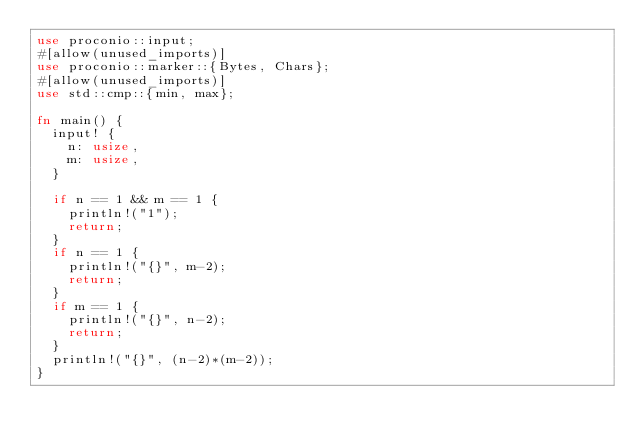<code> <loc_0><loc_0><loc_500><loc_500><_Rust_>use proconio::input;
#[allow(unused_imports)]
use proconio::marker::{Bytes, Chars};
#[allow(unused_imports)]
use std::cmp::{min, max};

fn main() {
	input! {
		n: usize,
		m: usize,
	}

	if n == 1 && m == 1 {
		println!("1");
		return;
	}
	if n == 1 {
		println!("{}", m-2);
		return;
	}
	if m == 1 {
		println!("{}", n-2);
		return;
	}
	println!("{}", (n-2)*(m-2));
}

</code> 